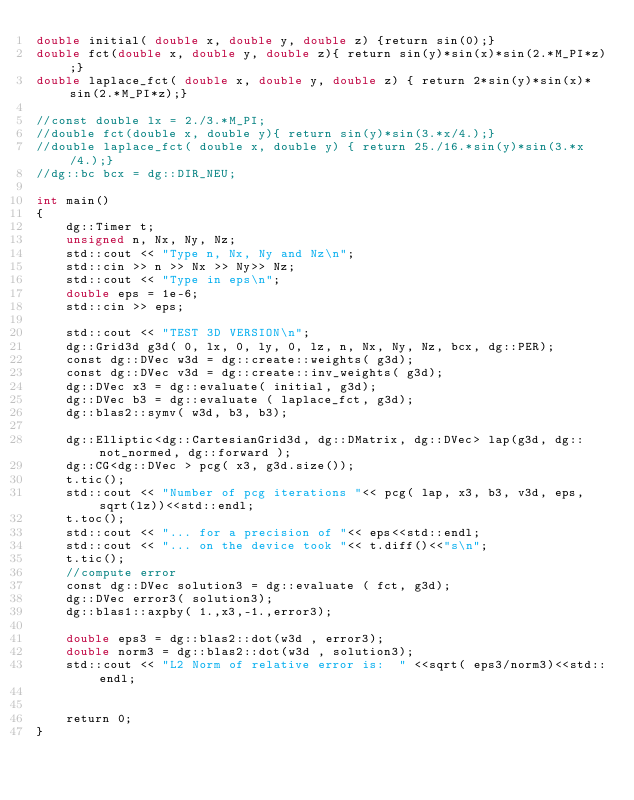Convert code to text. <code><loc_0><loc_0><loc_500><loc_500><_Cuda_>double initial( double x, double y, double z) {return sin(0);}
double fct(double x, double y, double z){ return sin(y)*sin(x)*sin(2.*M_PI*z);}
double laplace_fct( double x, double y, double z) { return 2*sin(y)*sin(x)*sin(2.*M_PI*z);}

//const double lx = 2./3.*M_PI;
//double fct(double x, double y){ return sin(y)*sin(3.*x/4.);}
//double laplace_fct( double x, double y) { return 25./16.*sin(y)*sin(3.*x/4.);}
//dg::bc bcx = dg::DIR_NEU;

int main()
{
    dg::Timer t;
    unsigned n, Nx, Ny, Nz;
    std::cout << "Type n, Nx, Ny and Nz\n";
    std::cin >> n >> Nx >> Ny>> Nz;
    std::cout << "Type in eps\n";
    double eps = 1e-6;
    std::cin >> eps;

    std::cout << "TEST 3D VERSION\n";
    dg::Grid3d g3d( 0, lx, 0, ly, 0, lz, n, Nx, Ny, Nz, bcx, dg::PER);
    const dg::DVec w3d = dg::create::weights( g3d);
    const dg::DVec v3d = dg::create::inv_weights( g3d);
    dg::DVec x3 = dg::evaluate( initial, g3d);
    dg::DVec b3 = dg::evaluate ( laplace_fct, g3d);
    dg::blas2::symv( w3d, b3, b3);

    dg::Elliptic<dg::CartesianGrid3d, dg::DMatrix, dg::DVec> lap(g3d, dg::not_normed, dg::forward );
    dg::CG<dg::DVec > pcg( x3, g3d.size());
    t.tic();
    std::cout << "Number of pcg iterations "<< pcg( lap, x3, b3, v3d, eps, sqrt(lz))<<std::endl;
    t.toc();
    std::cout << "... for a precision of "<< eps<<std::endl;
    std::cout << "... on the device took "<< t.diff()<<"s\n";
    t.tic();
    //compute error
    const dg::DVec solution3 = dg::evaluate ( fct, g3d);
    dg::DVec error3( solution3);
    dg::blas1::axpby( 1.,x3,-1.,error3);

    double eps3 = dg::blas2::dot(w3d , error3);
    double norm3 = dg::blas2::dot(w3d , solution3);
    std::cout << "L2 Norm of relative error is:  " <<sqrt( eps3/norm3)<<std::endl;


    return 0;
}
</code> 